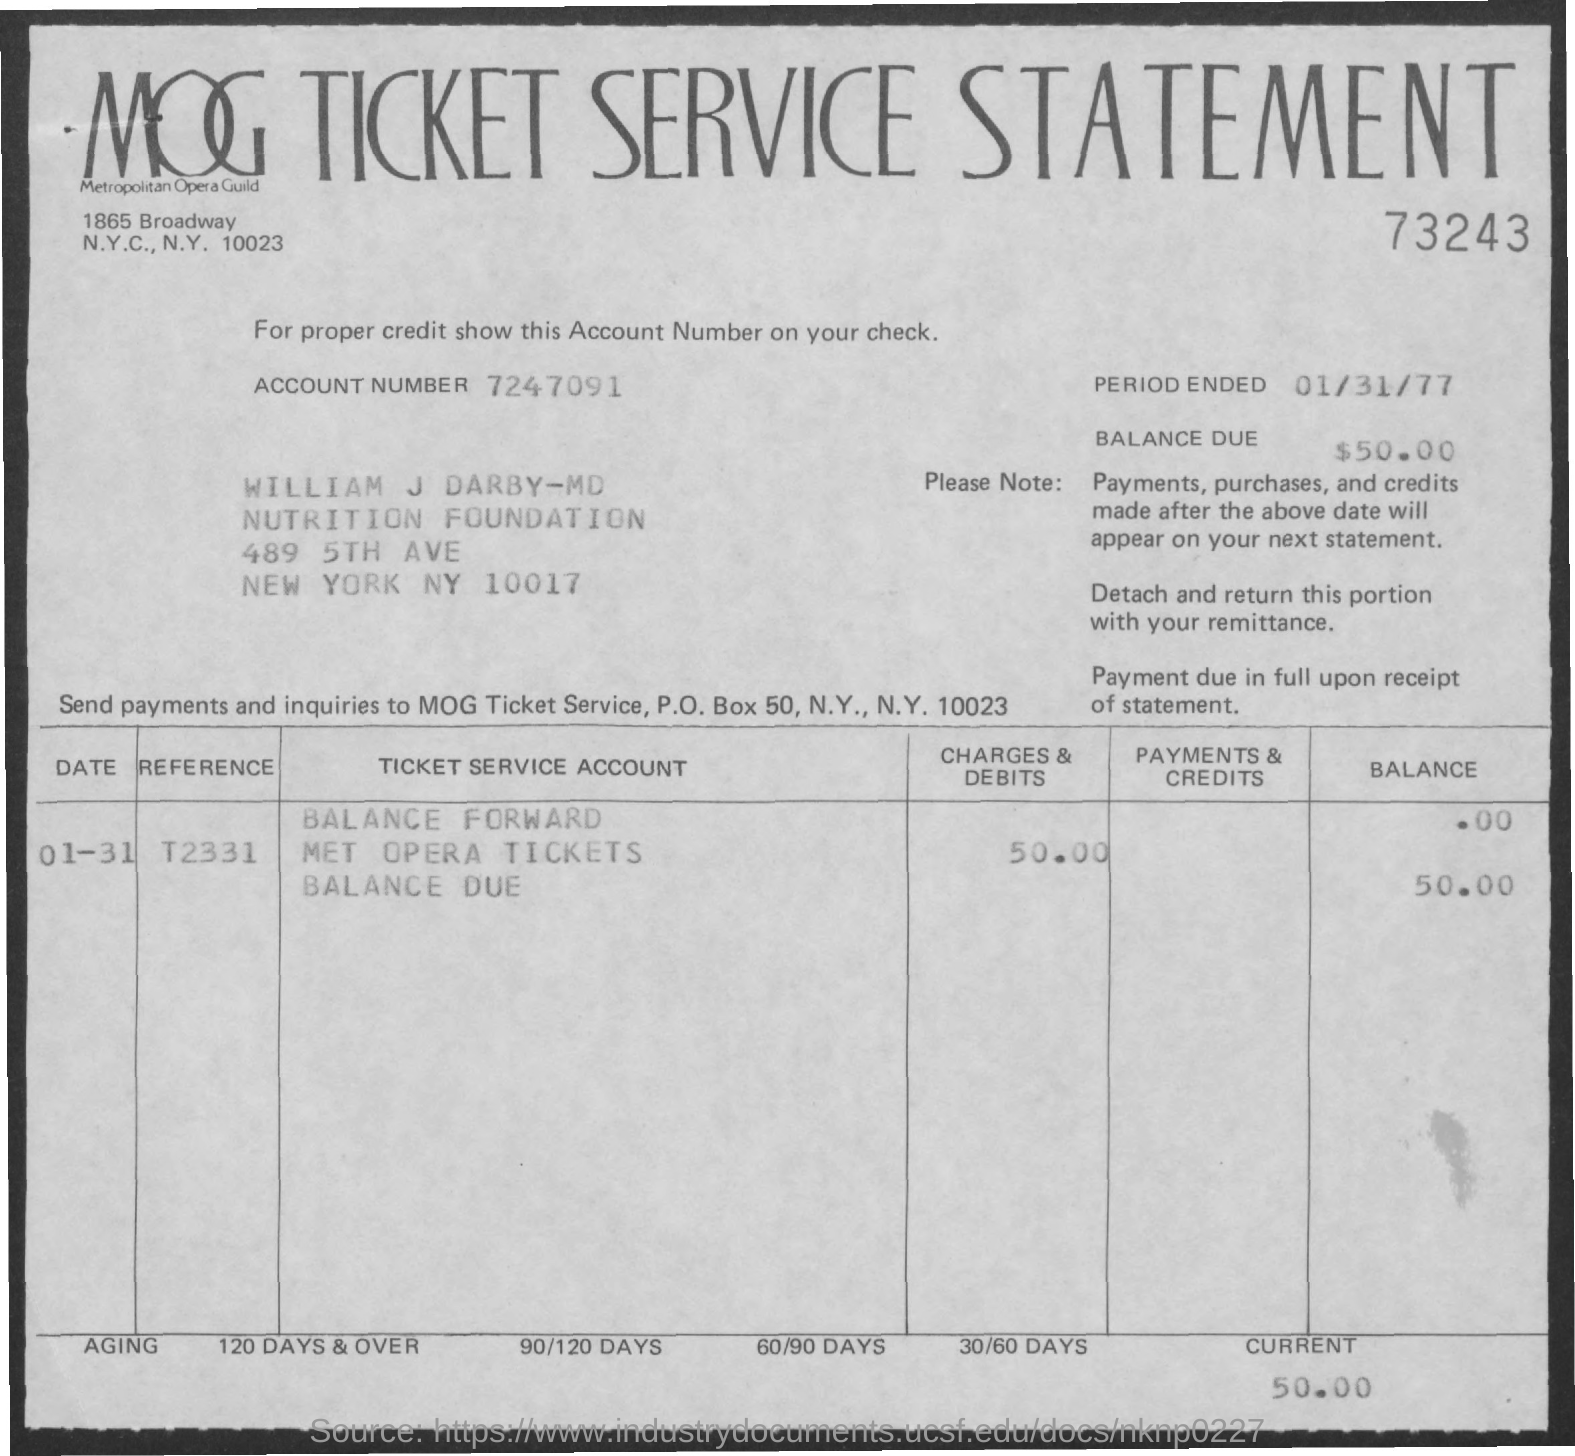What is the title of the document?
Offer a terse response. MOG Ticket Service Statement. What is the Account number?
Ensure brevity in your answer.  7247091. What is the Reference Number?
Offer a very short reply. T2331. What is the current balance?
Your response must be concise. 50.00. Which number is written directly below the title?
Provide a succinct answer. 73243. What is the end period?
Provide a short and direct response. 01/31/77. 